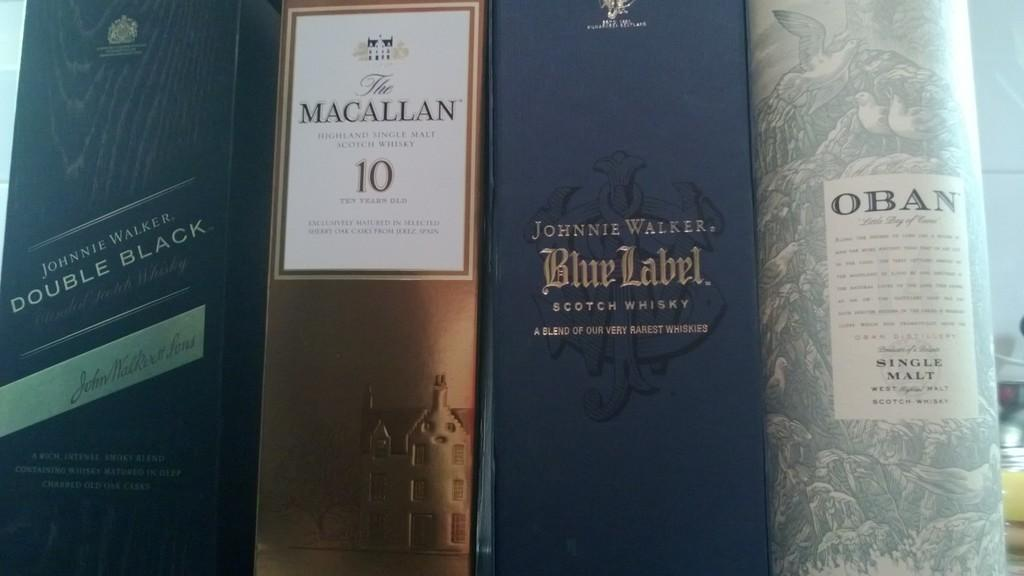<image>
Describe the image concisely. A group of alcoholic drinks with at least two whiskeys. 